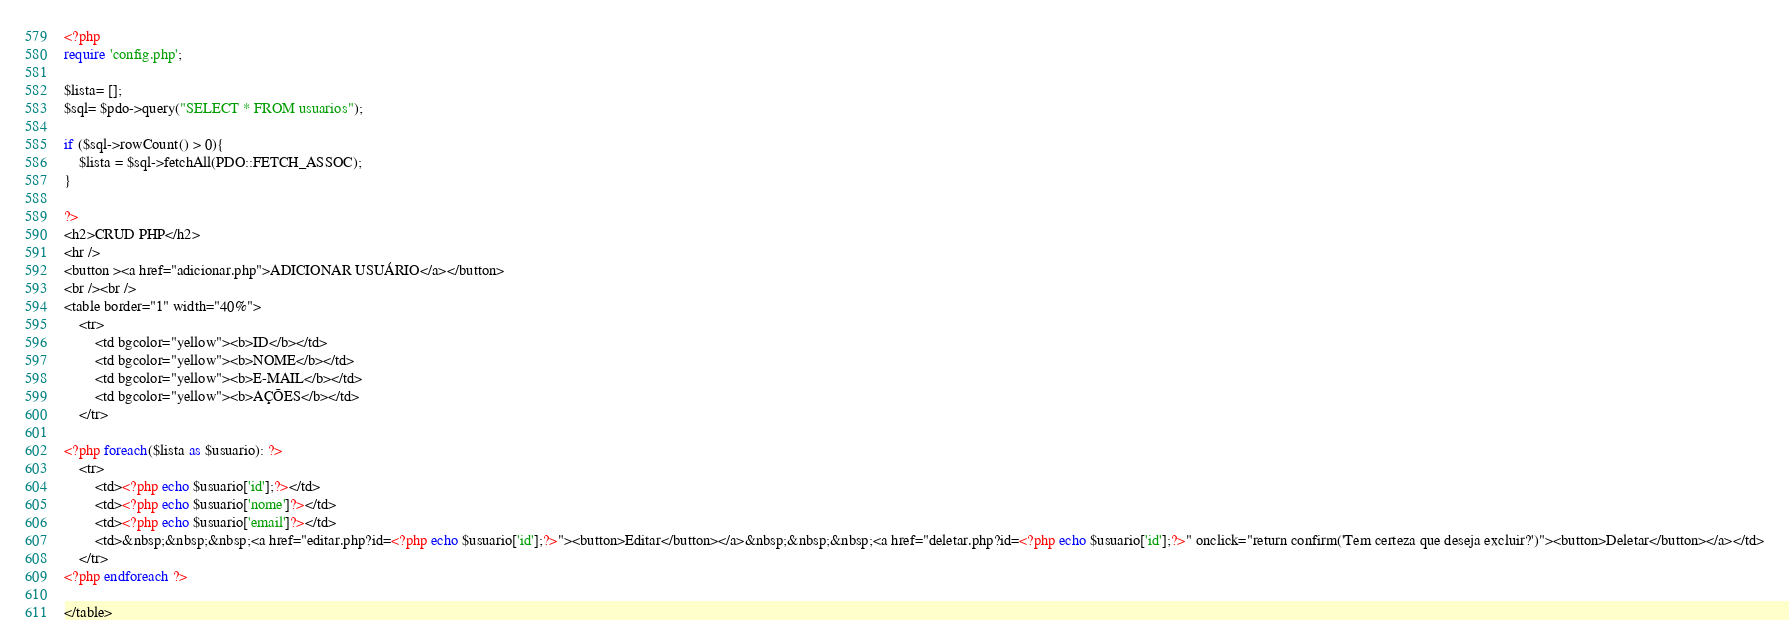Convert code to text. <code><loc_0><loc_0><loc_500><loc_500><_PHP_><?php
require 'config.php';

$lista= [];
$sql= $pdo->query("SELECT * FROM usuarios");

if ($sql->rowCount() > 0){
    $lista = $sql->fetchAll(PDO::FETCH_ASSOC);
}

?>
<h2>CRUD PHP</h2>
<hr /> 
<button ><a href="adicionar.php">ADICIONAR USUÁRIO</a></button>
<br /><br />
<table border="1" width="40%">
    <tr>
        <td bgcolor="yellow"><b>ID</b></td>
        <td bgcolor="yellow"><b>NOME</b></td>
        <td bgcolor="yellow"><b>E-MAIL</b></td>
        <td bgcolor="yellow"><b>AÇÕES</b></td>
    </tr>
    
<?php foreach($lista as $usuario): ?>
    <tr>
        <td><?php echo $usuario['id'];?></td>
        <td><?php echo $usuario['nome']?></td>
        <td><?php echo $usuario['email']?></td>
        <td>&nbsp;&nbsp;&nbsp;<a href="editar.php?id=<?php echo $usuario['id'];?>"><button>Editar</button></a>&nbsp;&nbsp;&nbsp;<a href="deletar.php?id=<?php echo $usuario['id'];?>" onclick="return confirm('Tem certeza que deseja excluir?')"><button>Deletar</button></a></td>
    </tr>
<?php endforeach ?>

</table></code> 